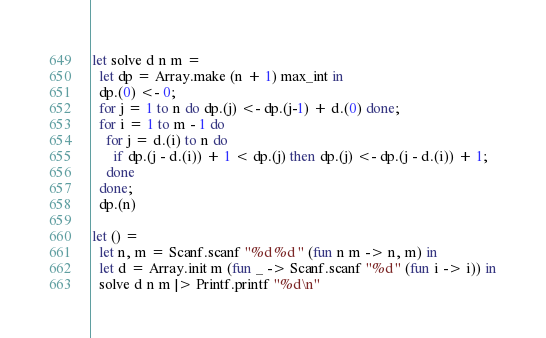Convert code to text. <code><loc_0><loc_0><loc_500><loc_500><_OCaml_>let solve d n m =
  let dp = Array.make (n + 1) max_int in
  dp.(0) <- 0;
  for j = 1 to n do dp.(j) <- dp.(j-1) + d.(0) done;
  for i = 1 to m - 1 do
    for j = d.(i) to n do
      if dp.(j - d.(i)) + 1 < dp.(j) then dp.(j) <- dp.(j - d.(i)) + 1;
    done
  done;
  dp.(n)

let () =
  let n, m = Scanf.scanf "%d %d " (fun n m -> n, m) in
  let d = Array.init m (fun _ -> Scanf.scanf "%d " (fun i -> i)) in
  solve d n m |> Printf.printf "%d\n"</code> 